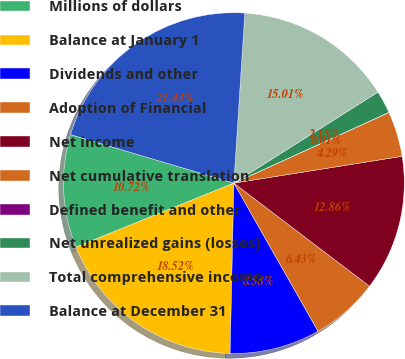Convert chart. <chart><loc_0><loc_0><loc_500><loc_500><pie_chart><fcel>Millions of dollars<fcel>Balance at January 1<fcel>Dividends and other<fcel>Adoption of Financial<fcel>Net income<fcel>Net cumulative translation<fcel>Defined benefit and other<fcel>Net unrealized gains (losses)<fcel>Total comprehensive income<fcel>Balance at December 31<nl><fcel>10.72%<fcel>18.52%<fcel>8.58%<fcel>6.43%<fcel>12.86%<fcel>4.29%<fcel>0.01%<fcel>2.15%<fcel>15.01%<fcel>21.43%<nl></chart> 